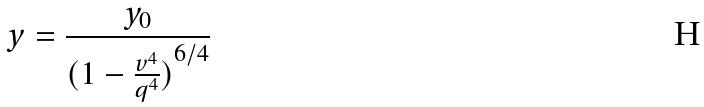<formula> <loc_0><loc_0><loc_500><loc_500>y = \frac { y _ { 0 } } { ( { 1 - \frac { v ^ { 4 } } { q ^ { 4 } } ) } ^ { 6 / 4 } }</formula> 